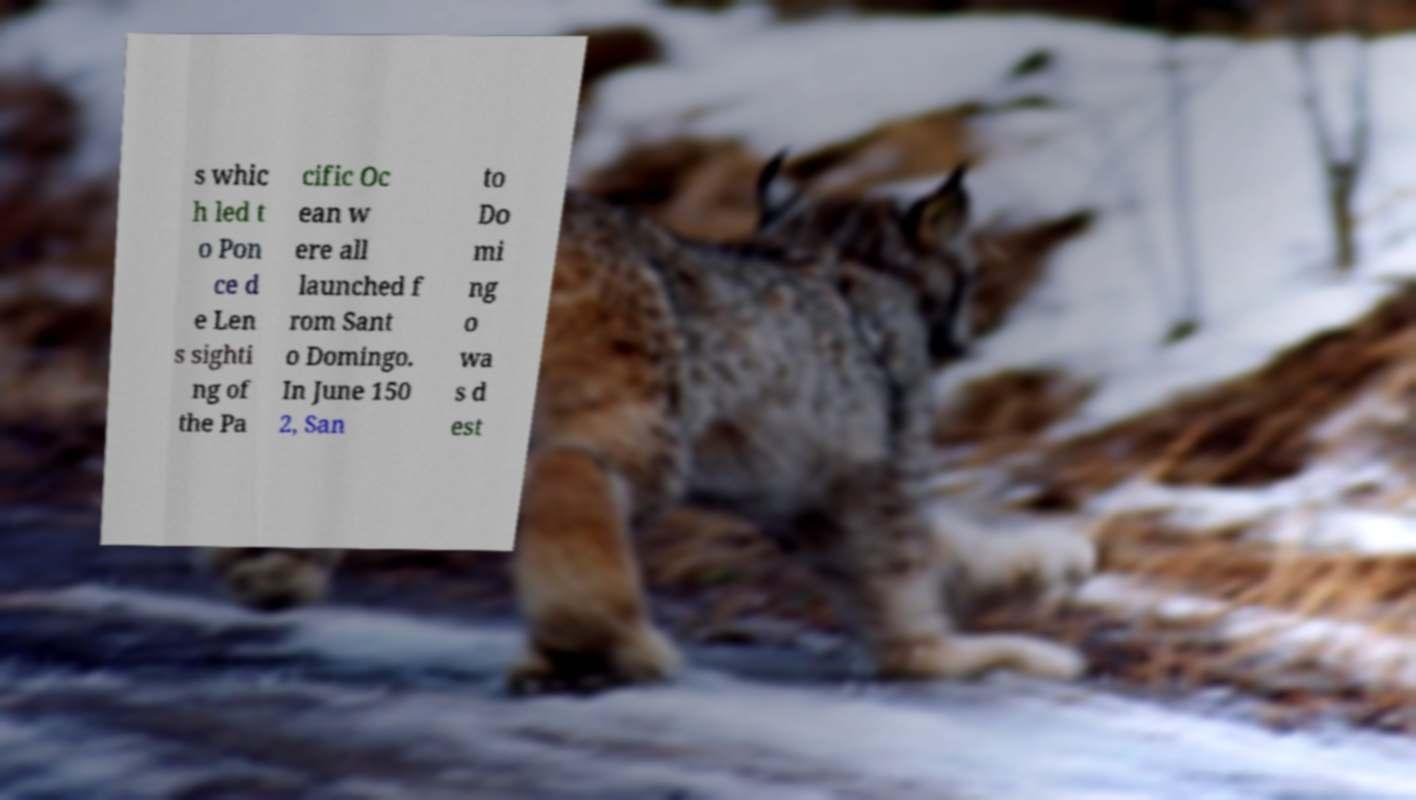Can you read and provide the text displayed in the image?This photo seems to have some interesting text. Can you extract and type it out for me? s whic h led t o Pon ce d e Len s sighti ng of the Pa cific Oc ean w ere all launched f rom Sant o Domingo. In June 150 2, San to Do mi ng o wa s d est 